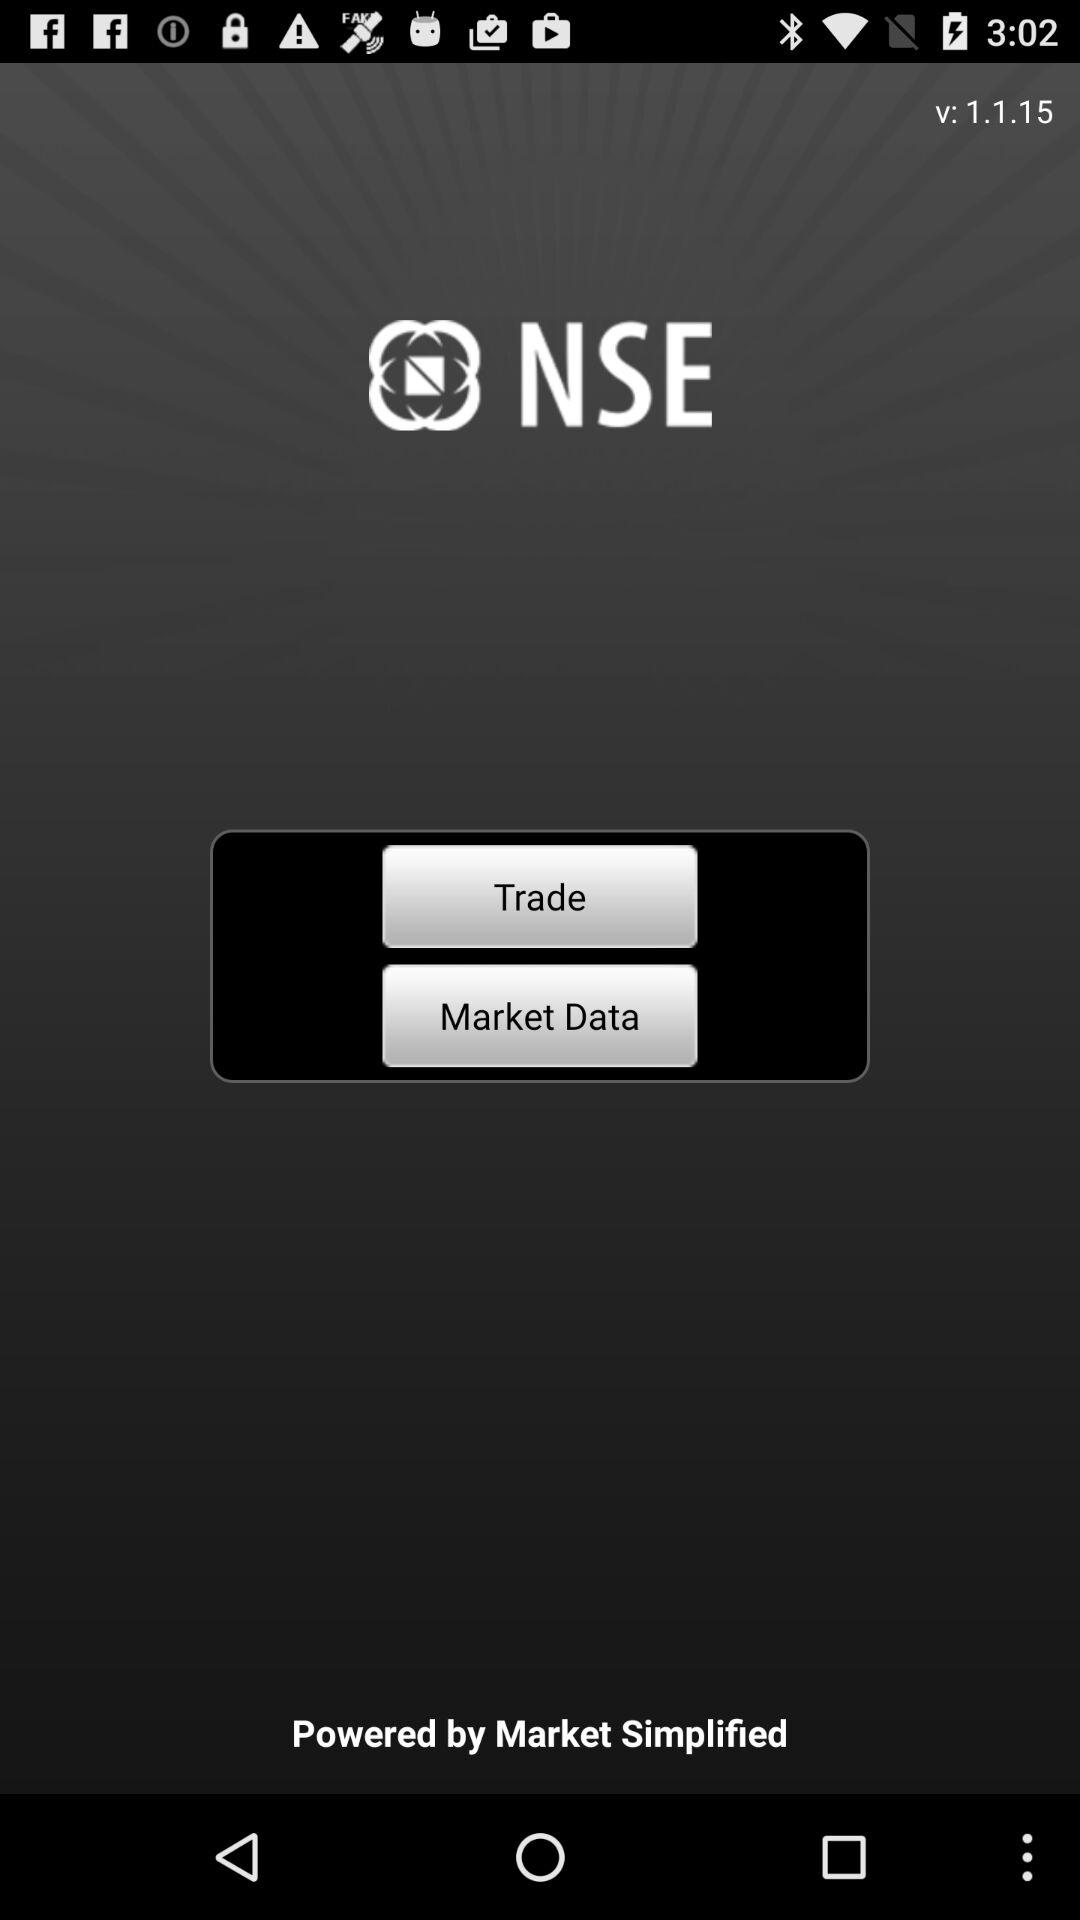What is the version of the application being used? The version of the application being used is 1.1.15. 